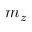Convert formula to latex. <formula><loc_0><loc_0><loc_500><loc_500>m _ { z }</formula> 